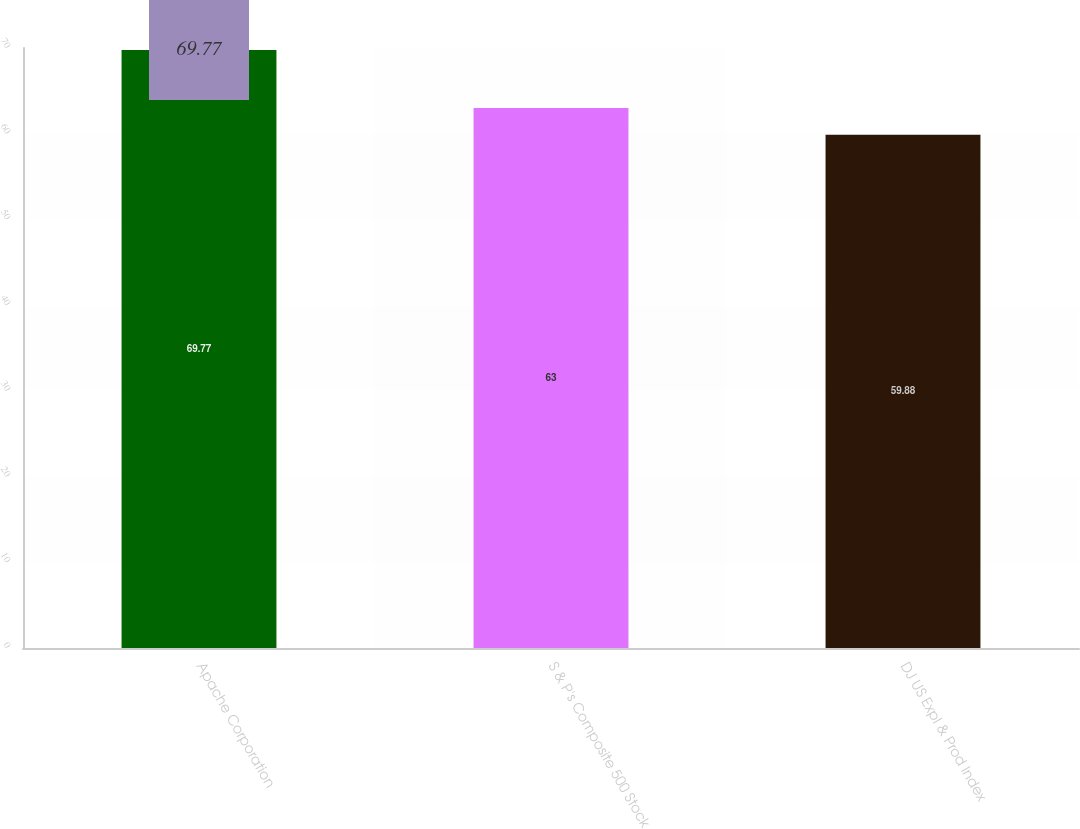Convert chart. <chart><loc_0><loc_0><loc_500><loc_500><bar_chart><fcel>Apache Corporation<fcel>S & P's Composite 500 Stock<fcel>DJ US Expl & Prod Index<nl><fcel>69.77<fcel>63<fcel>59.88<nl></chart> 